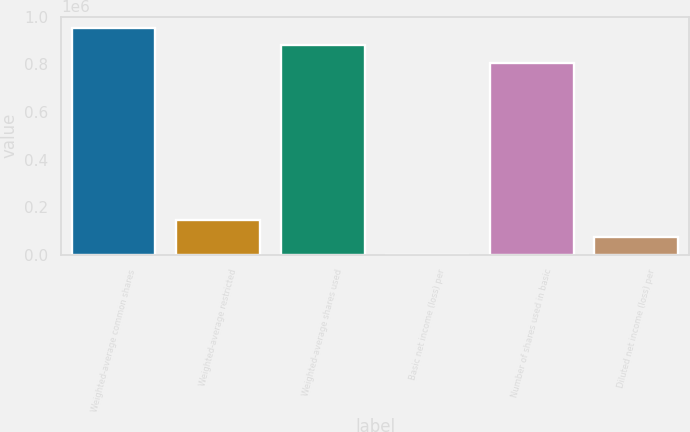Convert chart. <chart><loc_0><loc_0><loc_500><loc_500><bar_chart><fcel>Weighted-average common shares<fcel>Weighted-average restricted<fcel>Weighted-average shares used<fcel>Basic net income (loss) per<fcel>Number of shares used in basic<fcel>Diluted net income (loss) per<nl><fcel>953684<fcel>147322<fcel>880023<fcel>0.15<fcel>806363<fcel>73660.8<nl></chart> 